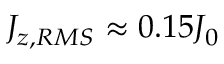<formula> <loc_0><loc_0><loc_500><loc_500>J _ { z , R M S } \approx 0 . 1 5 J _ { 0 }</formula> 